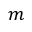<formula> <loc_0><loc_0><loc_500><loc_500>m</formula> 